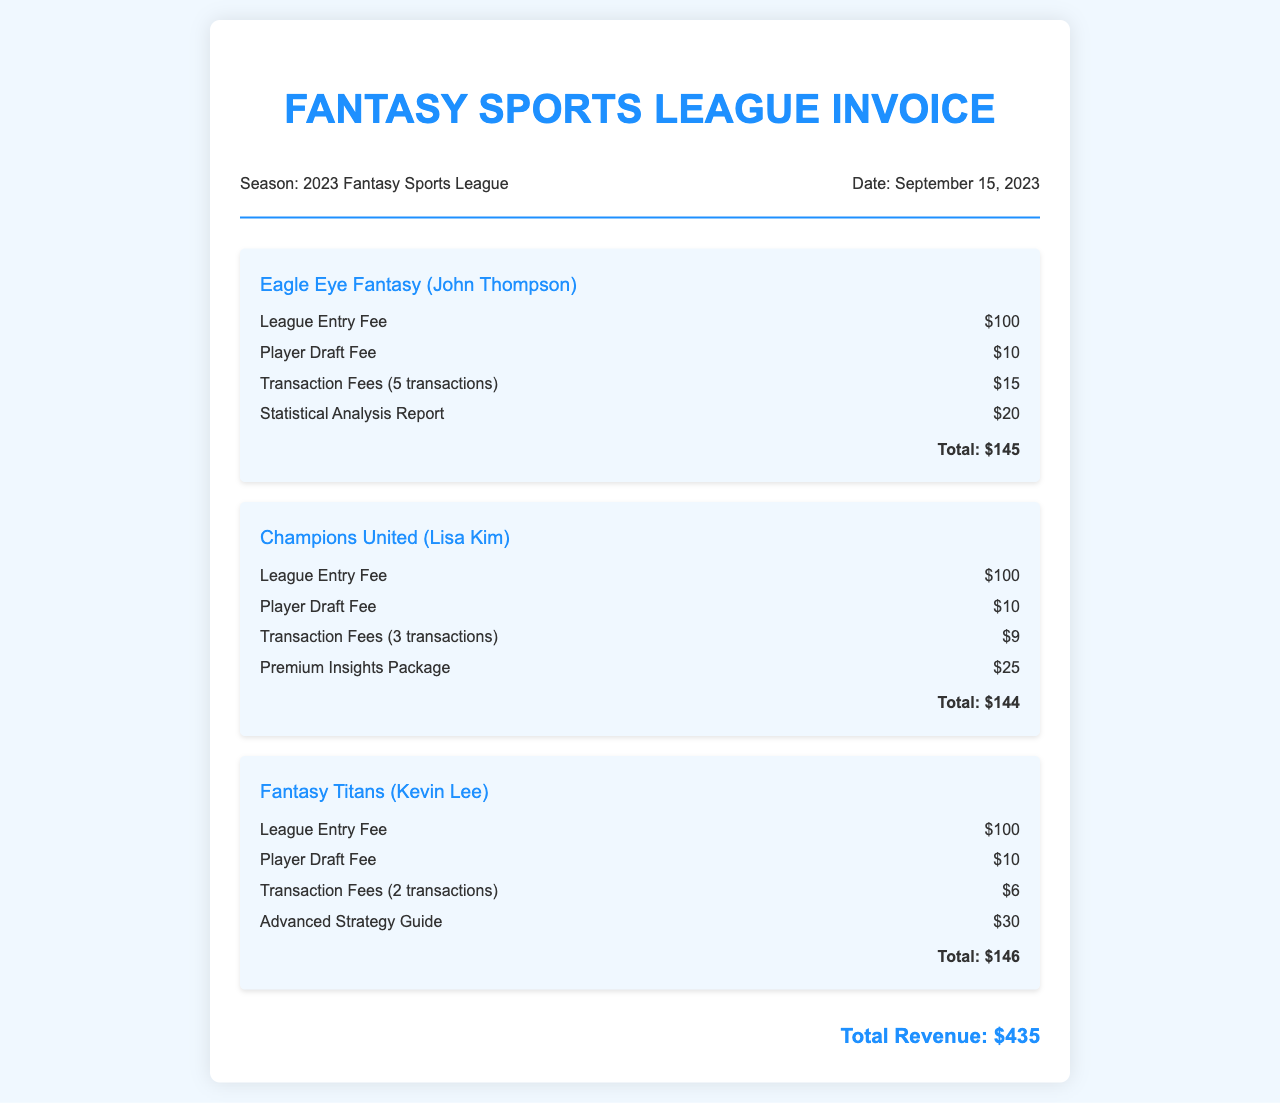What is the season for this invoice? The season specified in the invoice is the 2023 Fantasy Sports League.
Answer: 2023 Fantasy Sports League What is the date on the invoice? The invoice date is mentioned as September 15, 2023.
Answer: September 15, 2023 Who is the team owner for Eagle Eye Fantasy? The invoice specifies John Thompson as the team owner for Eagle Eye Fantasy.
Answer: John Thompson What is the total for Champions United? The total charge for Champions United is $144.
Answer: $144 How many transactions were included for Fantasy Titans? The document states there were 2 transactions for Fantasy Titans.
Answer: 2 transactions What was the Statistical Analysis Report charge? The charge for the Statistical Analysis Report is listed as $20.
Answer: $20 What is the total revenue listed in the invoice? The total revenue is the sum of all the teams' totals, which is $435.
Answer: $435 What is the item for the fee charged at $10? The invoice lists the Player Draft Fee as the service charged at $10.
Answer: Player Draft Fee What additional service did Champions United purchase? The additional service purchased by Champions United is the Premium Insights Package.
Answer: Premium Insights Package What is the total for Eagle Eye Fantasy? The total charge for Eagle Eye Fantasy is $145.
Answer: $145 